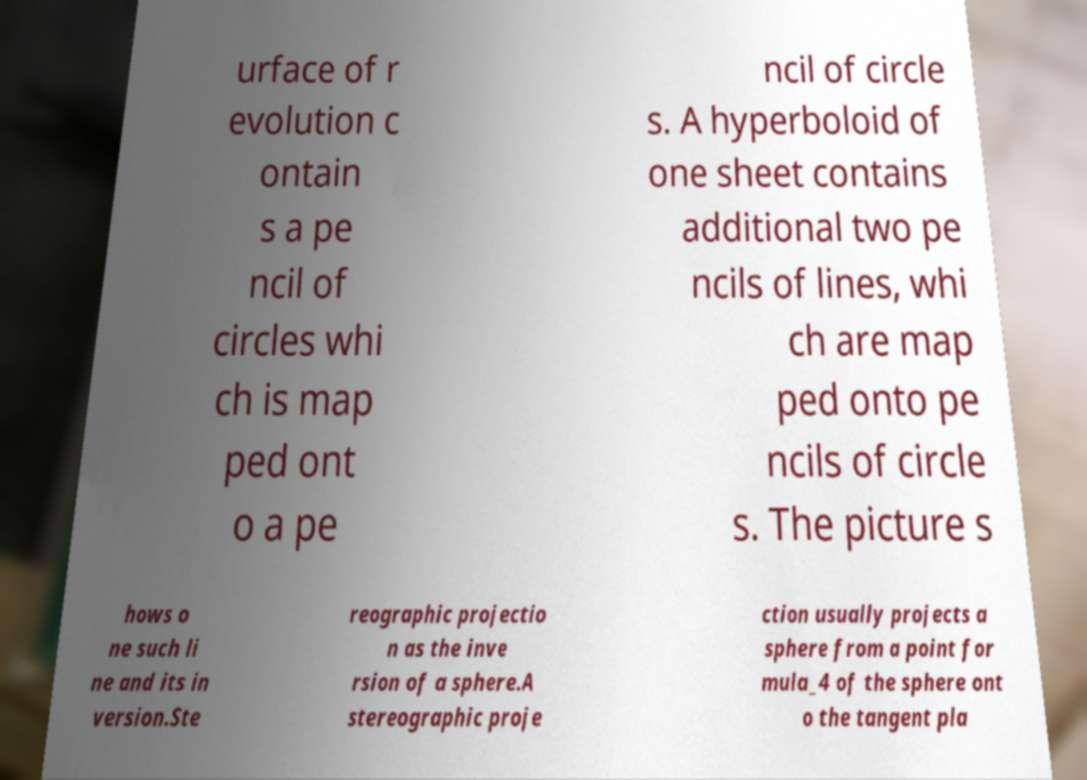Could you extract and type out the text from this image? urface of r evolution c ontain s a pe ncil of circles whi ch is map ped ont o a pe ncil of circle s. A hyperboloid of one sheet contains additional two pe ncils of lines, whi ch are map ped onto pe ncils of circle s. The picture s hows o ne such li ne and its in version.Ste reographic projectio n as the inve rsion of a sphere.A stereographic proje ction usually projects a sphere from a point for mula_4 of the sphere ont o the tangent pla 